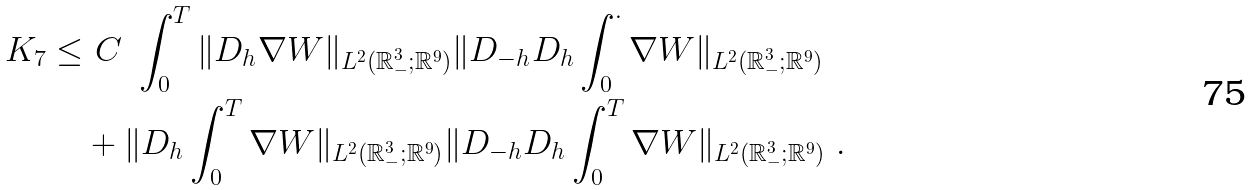<formula> <loc_0><loc_0><loc_500><loc_500>K _ { 7 } \leq & \ C \ \int _ { 0 } ^ { T } \| D _ { h } \nabla { W } \| _ { L ^ { 2 } ( { \mathbb { R } } ^ { 3 } _ { - } ; { \mathbb { R } } ^ { 9 } ) } \| D _ { - h } D _ { h } \int _ { 0 } ^ { \cdot } { \nabla W } \| _ { L ^ { 2 } ( { \mathbb { R } } ^ { 3 } _ { - } ; { \mathbb { R } } ^ { 9 } ) } \\ & + \| D _ { h } \int _ { 0 } ^ { T } \nabla { W } \| _ { L ^ { 2 } ( { \mathbb { R } } ^ { 3 } _ { - } ; { \mathbb { R } } ^ { 9 } ) } \| D _ { - h } D _ { h } \int _ { 0 } ^ { T } \nabla { W } \| _ { L ^ { 2 } ( { \mathbb { R } } ^ { 3 } _ { - } ; { \mathbb { R } } ^ { 9 } ) } \ .</formula> 